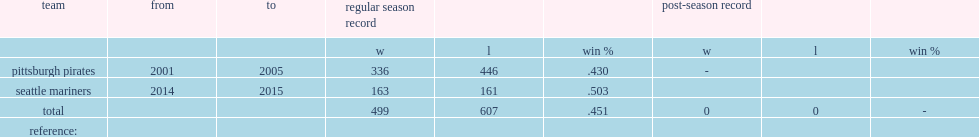When did lloyd mcclendon become the manager of the pittsburgh pirates? 2001.0. 